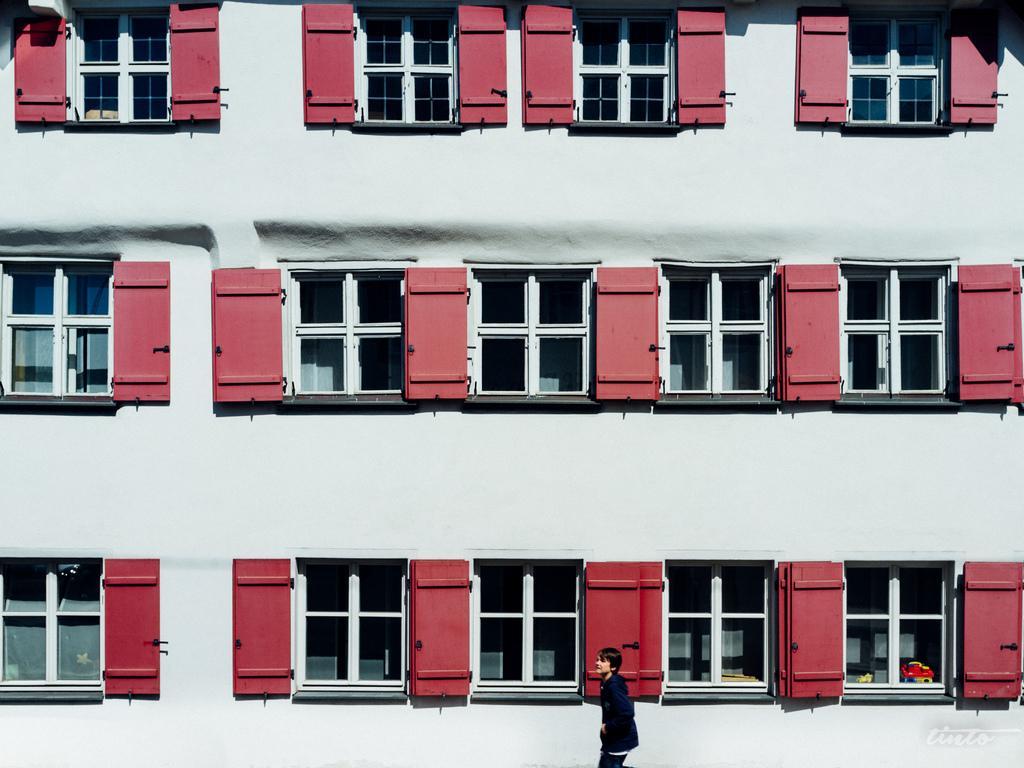In one or two sentences, can you explain what this image depicts? In this image there is a building and also we could see windows, and at the bottom there is one person. 